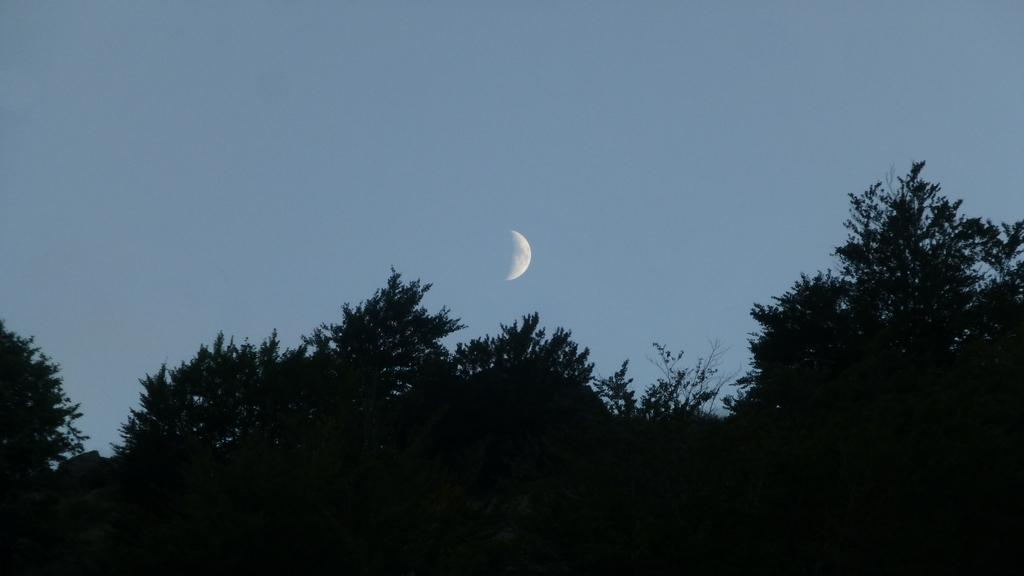What type of vegetation is at the bottom of the image? There are trees at the bottom of the image. What can be seen in the background of the image? The sky and the moon are visible in the background of the image. What type of straw is being used to transport the governor in the image? There is no straw or governor present in the image. How is the governor being transported in the image? There is no governor or transportation depicted in the image. 